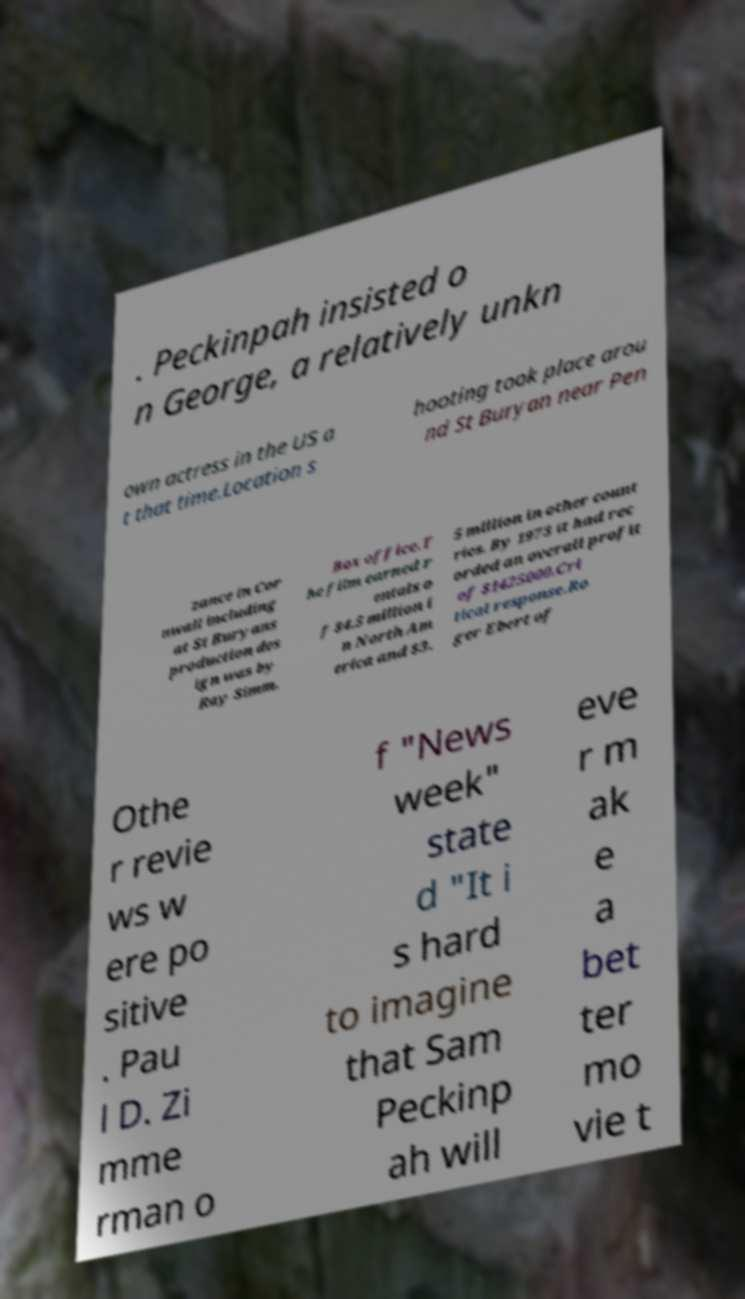Could you extract and type out the text from this image? . Peckinpah insisted o n George, a relatively unkn own actress in the US a t that time.Location s hooting took place arou nd St Buryan near Pen zance in Cor nwall including at St Buryans production des ign was by Ray Simm. Box office.T he film earned r entals o f $4.5 million i n North Am erica and $3. 5 million in other count ries. By 1973 it had rec orded an overall profit of $1425000.Cri tical response.Ro ger Ebert of Othe r revie ws w ere po sitive . Pau l D. Zi mme rman o f "News week" state d "It i s hard to imagine that Sam Peckinp ah will eve r m ak e a bet ter mo vie t 